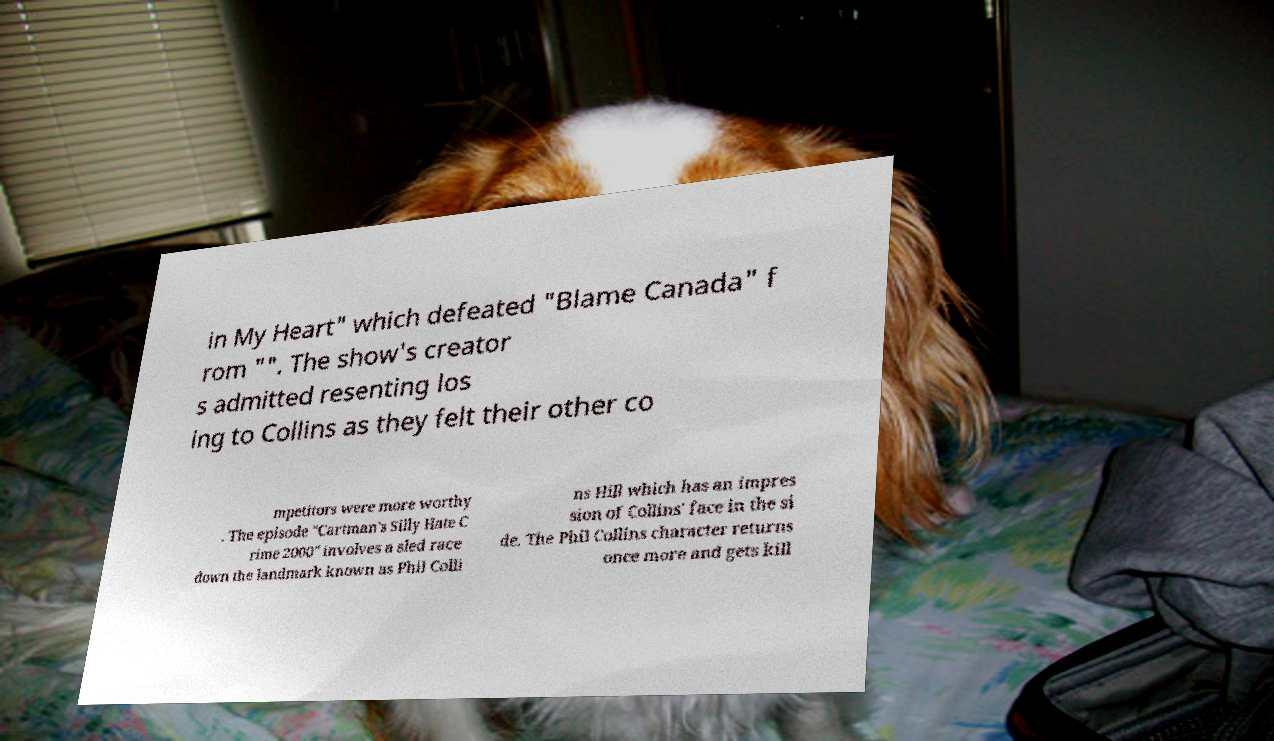Please identify and transcribe the text found in this image. in My Heart" which defeated "Blame Canada" f rom "". The show's creator s admitted resenting los ing to Collins as they felt their other co mpetitors were more worthy . The episode "Cartman's Silly Hate C rime 2000" involves a sled race down the landmark known as Phil Colli ns Hill which has an impres sion of Collins' face in the si de. The Phil Collins character returns once more and gets kill 